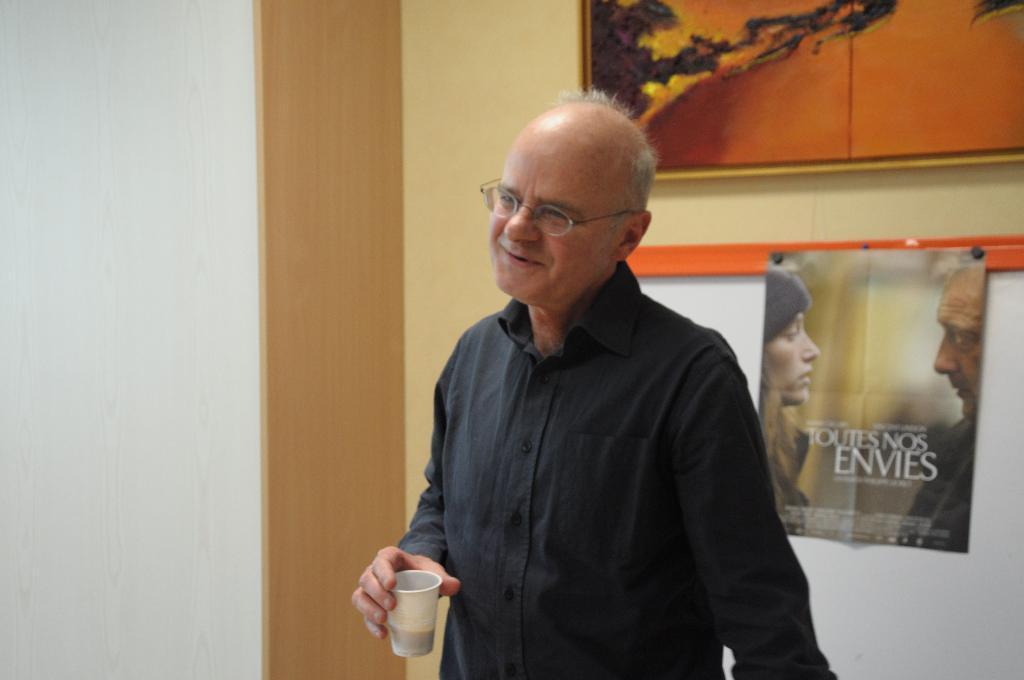In one or two sentences, can you explain what this image depicts? In this image we can see a person holding a glass, there is a photo frame and a board, on the board, we can see a poster and also we can see the wall. 